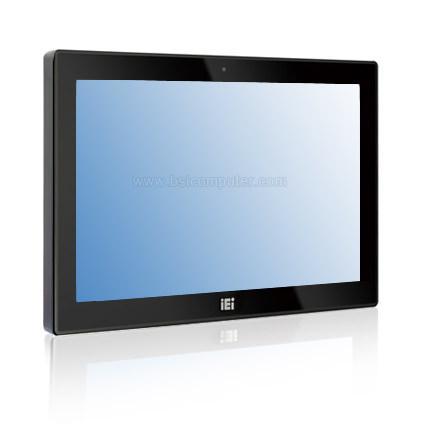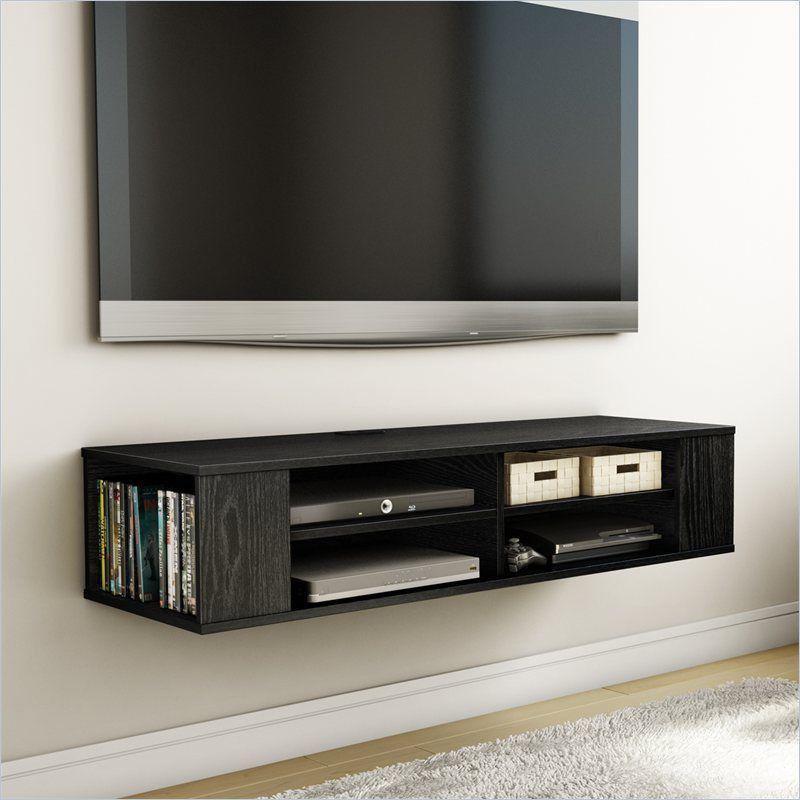The first image is the image on the left, the second image is the image on the right. Given the left and right images, does the statement "One picture shows a TV above a piece of furniture." hold true? Answer yes or no. Yes. The first image is the image on the left, the second image is the image on the right. For the images shown, is this caption "Each image contains a rectangular gray-black screen that is displayed head-on instead of at an angle." true? Answer yes or no. No. 